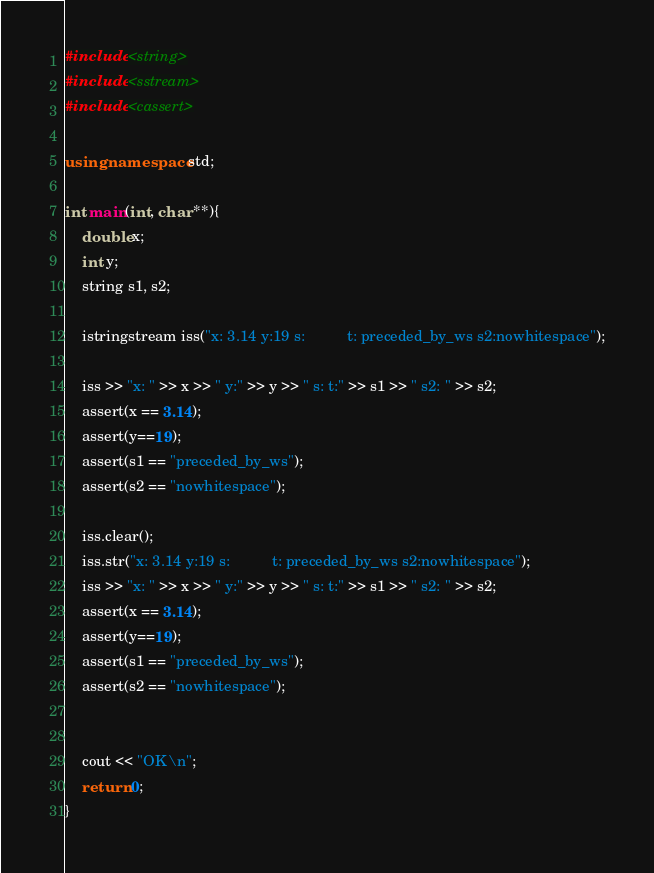<code> <loc_0><loc_0><loc_500><loc_500><_C++_>#include <string>
#include <sstream>
#include <cassert>

using namespace std;

int main(int, char **){
    double x;
    int y;
    string s1, s2;

    istringstream iss("x: 3.14 y:19 s:          t: preceded_by_ws s2:nowhitespace");

    iss >> "x: " >> x >> " y:" >> y >> " s: t:" >> s1 >> " s2: " >> s2;
    assert(x == 3.14);
    assert(y==19);
    assert(s1 == "preceded_by_ws");
    assert(s2 == "nowhitespace");

    iss.clear();
    iss.str("x: 3.14 y:19 s:          t: preceded_by_ws s2:nowhitespace");
    iss >> "x: " >> x >> " y:" >> y >> " s: t:" >> s1 >> " s2: " >> s2;
    assert(x == 3.14);
    assert(y==19);
    assert(s1 == "preceded_by_ws");
    assert(s2 == "nowhitespace");


    cout << "OK\n";
    return 0;
}
</code> 